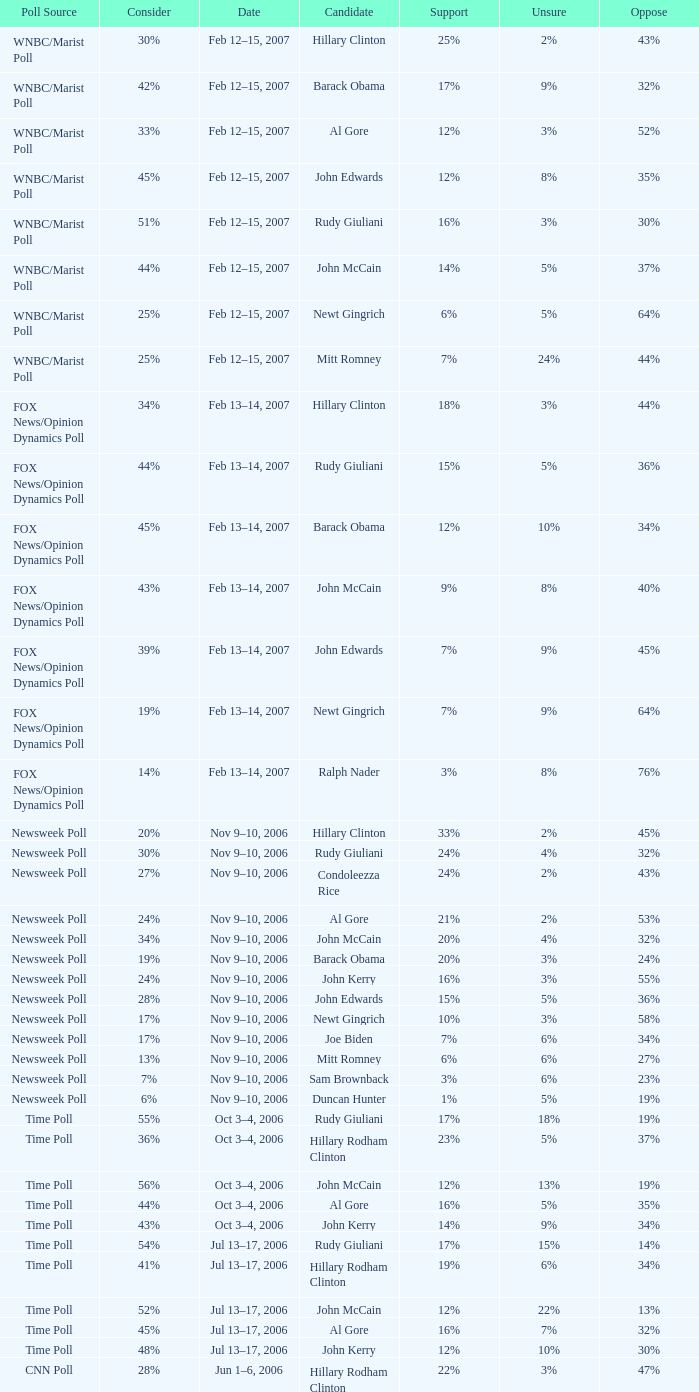What percentage of people said they would consider Rudy Giuliani as a candidate according to the Newsweek poll that showed 32% opposed him? 30%. 